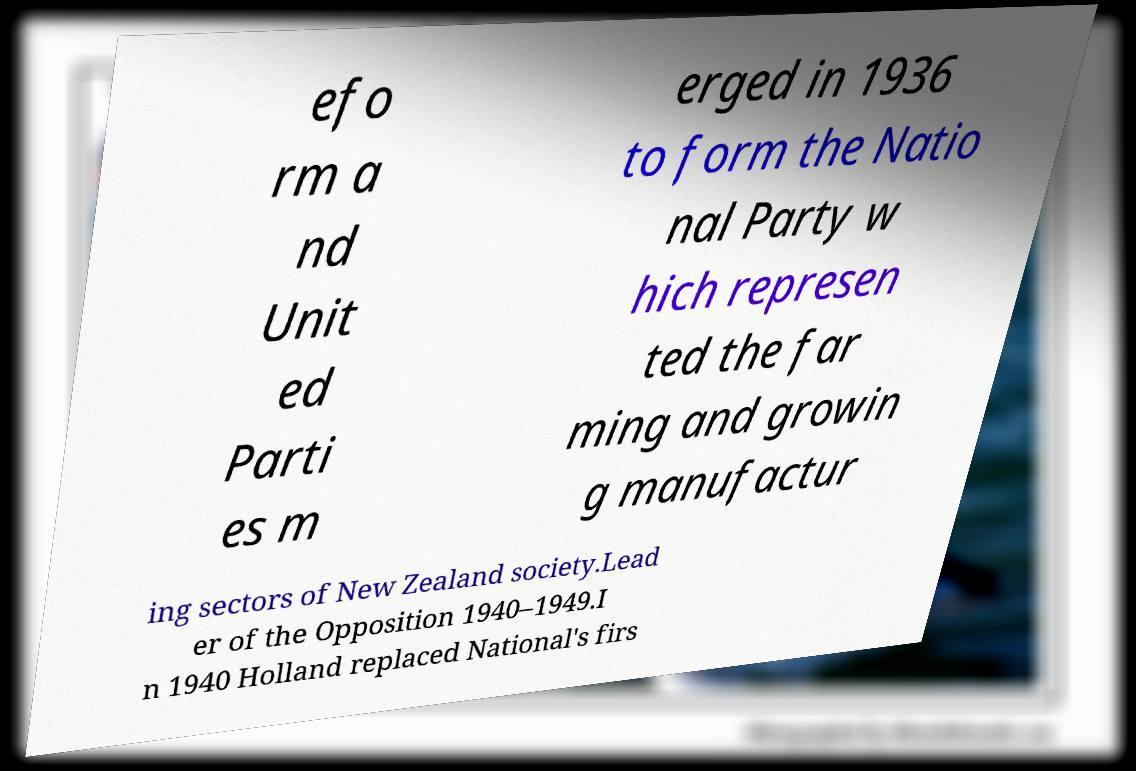Can you read and provide the text displayed in the image?This photo seems to have some interesting text. Can you extract and type it out for me? efo rm a nd Unit ed Parti es m erged in 1936 to form the Natio nal Party w hich represen ted the far ming and growin g manufactur ing sectors of New Zealand society.Lead er of the Opposition 1940–1949.I n 1940 Holland replaced National's firs 